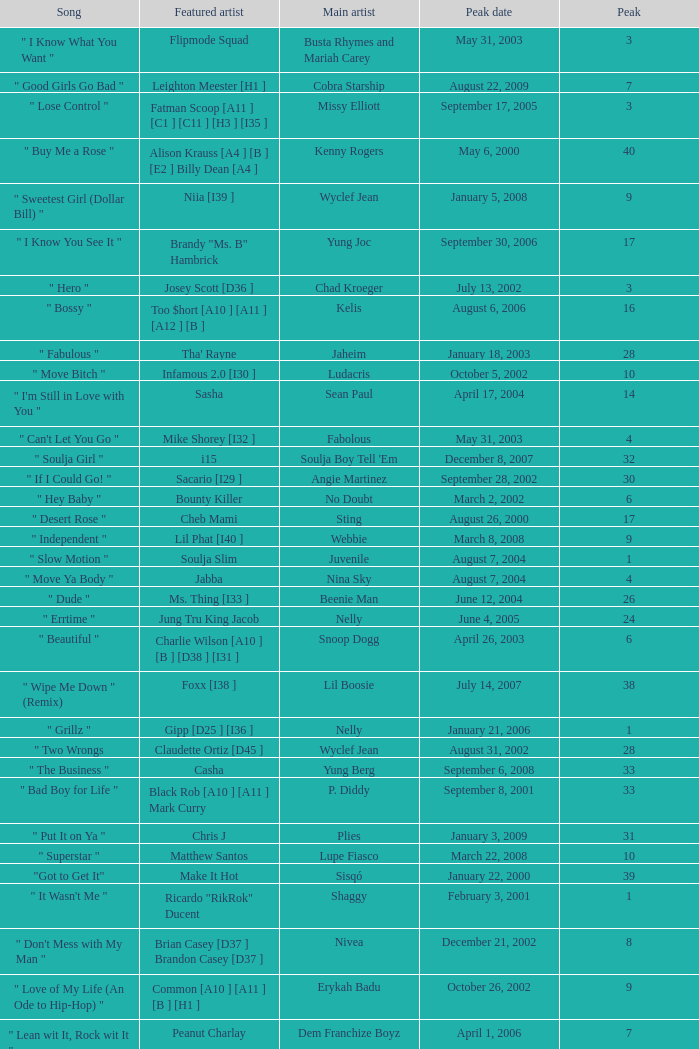What was the peak date of Kelis's song? August 6, 2006. 